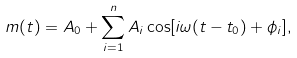Convert formula to latex. <formula><loc_0><loc_0><loc_500><loc_500>m ( t ) = A _ { 0 } + \sum _ { i = 1 } ^ { n } A _ { i } \cos [ i \omega ( t - t _ { 0 } ) + \phi _ { i } ] ,</formula> 